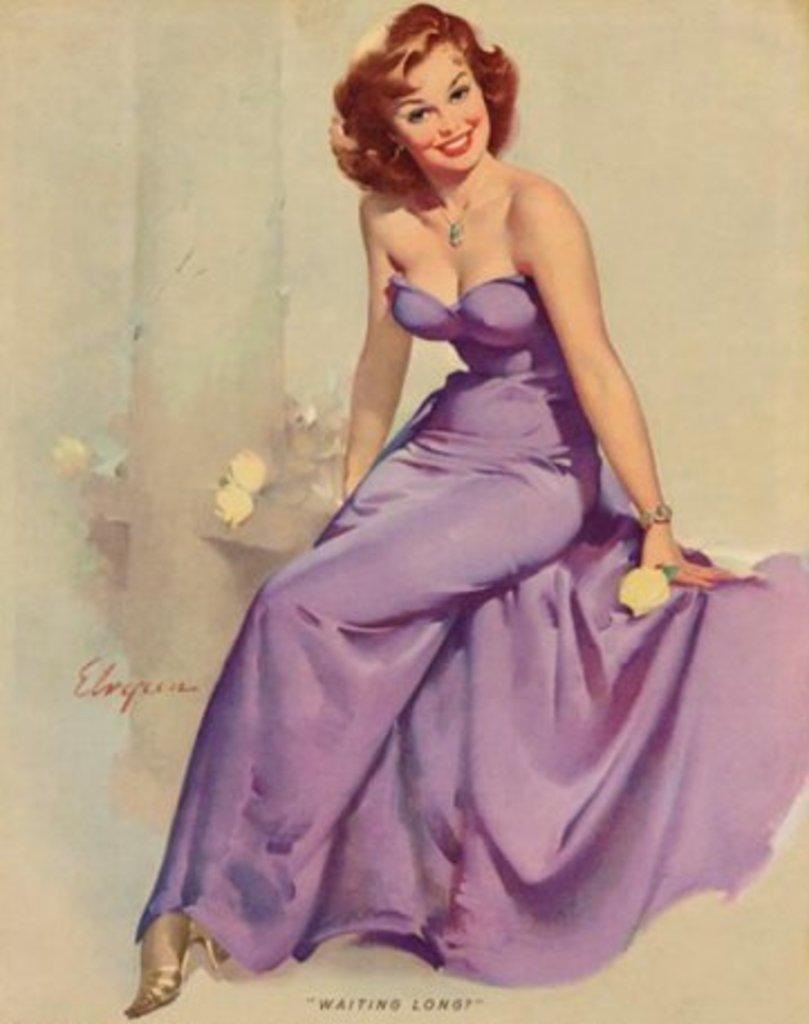What is the main subject in the foreground of the image? There is a painting in the foreground of the image. What is the lady in the painting doing? The lady in the painting is sitting on a stone. What can be seen beside the lady in the painting? There are flowers and a pillar beside the lady in the painting. How would you describe the background of the painting? The background of the painting is cream-colored. What type of toy can be seen being used by the lady in the painting? There is no toy present in the painting; the lady is sitting on a stone with flowers and a pillar beside her. Is the lady in the painting skating on the stone? No, the lady is sitting on the stone, not skating. 